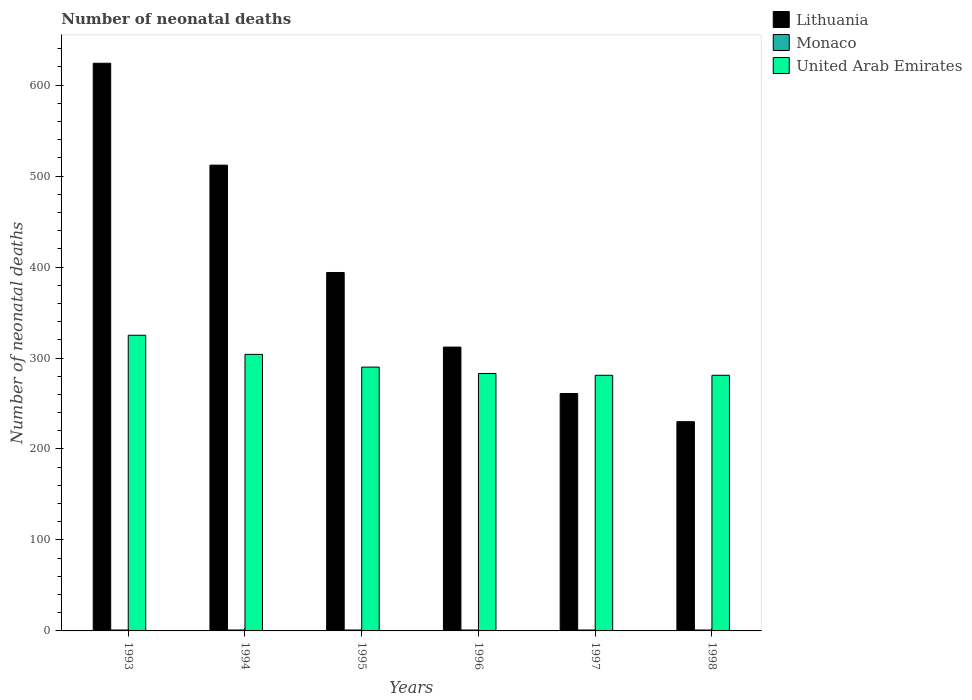Are the number of bars per tick equal to the number of legend labels?
Provide a short and direct response. Yes. Are the number of bars on each tick of the X-axis equal?
Your response must be concise. Yes. How many bars are there on the 5th tick from the left?
Offer a very short reply. 3. In how many cases, is the number of bars for a given year not equal to the number of legend labels?
Make the answer very short. 0. What is the number of neonatal deaths in in Lithuania in 1997?
Your answer should be very brief. 261. Across all years, what is the maximum number of neonatal deaths in in United Arab Emirates?
Keep it short and to the point. 325. Across all years, what is the minimum number of neonatal deaths in in Monaco?
Provide a succinct answer. 1. In which year was the number of neonatal deaths in in United Arab Emirates maximum?
Give a very brief answer. 1993. What is the difference between the number of neonatal deaths in in United Arab Emirates in 1996 and that in 1997?
Make the answer very short. 2. What is the difference between the number of neonatal deaths in in Monaco in 1993 and the number of neonatal deaths in in United Arab Emirates in 1994?
Your response must be concise. -303. In the year 1997, what is the difference between the number of neonatal deaths in in Monaco and number of neonatal deaths in in Lithuania?
Ensure brevity in your answer.  -260. In how many years, is the number of neonatal deaths in in Monaco greater than 260?
Offer a terse response. 0. What is the ratio of the number of neonatal deaths in in Lithuania in 1993 to that in 1996?
Your response must be concise. 2. What is the difference between the highest and the second highest number of neonatal deaths in in United Arab Emirates?
Provide a short and direct response. 21. What is the difference between the highest and the lowest number of neonatal deaths in in Lithuania?
Provide a short and direct response. 394. In how many years, is the number of neonatal deaths in in United Arab Emirates greater than the average number of neonatal deaths in in United Arab Emirates taken over all years?
Offer a terse response. 2. Is the sum of the number of neonatal deaths in in Lithuania in 1993 and 1995 greater than the maximum number of neonatal deaths in in United Arab Emirates across all years?
Give a very brief answer. Yes. What does the 2nd bar from the left in 1997 represents?
Provide a succinct answer. Monaco. What does the 3rd bar from the right in 1993 represents?
Offer a very short reply. Lithuania. How many bars are there?
Your answer should be compact. 18. Are all the bars in the graph horizontal?
Your response must be concise. No. What is the difference between two consecutive major ticks on the Y-axis?
Give a very brief answer. 100. Does the graph contain any zero values?
Ensure brevity in your answer.  No. Does the graph contain grids?
Your answer should be compact. No. Where does the legend appear in the graph?
Give a very brief answer. Top right. How many legend labels are there?
Your answer should be compact. 3. How are the legend labels stacked?
Ensure brevity in your answer.  Vertical. What is the title of the graph?
Offer a terse response. Number of neonatal deaths. What is the label or title of the Y-axis?
Your answer should be very brief. Number of neonatal deaths. What is the Number of neonatal deaths in Lithuania in 1993?
Your answer should be very brief. 624. What is the Number of neonatal deaths of Monaco in 1993?
Provide a succinct answer. 1. What is the Number of neonatal deaths of United Arab Emirates in 1993?
Your response must be concise. 325. What is the Number of neonatal deaths of Lithuania in 1994?
Offer a very short reply. 512. What is the Number of neonatal deaths in United Arab Emirates in 1994?
Make the answer very short. 304. What is the Number of neonatal deaths of Lithuania in 1995?
Offer a terse response. 394. What is the Number of neonatal deaths of United Arab Emirates in 1995?
Provide a short and direct response. 290. What is the Number of neonatal deaths in Lithuania in 1996?
Offer a very short reply. 312. What is the Number of neonatal deaths in United Arab Emirates in 1996?
Provide a short and direct response. 283. What is the Number of neonatal deaths of Lithuania in 1997?
Keep it short and to the point. 261. What is the Number of neonatal deaths in Monaco in 1997?
Offer a terse response. 1. What is the Number of neonatal deaths in United Arab Emirates in 1997?
Ensure brevity in your answer.  281. What is the Number of neonatal deaths in Lithuania in 1998?
Provide a succinct answer. 230. What is the Number of neonatal deaths of United Arab Emirates in 1998?
Provide a short and direct response. 281. Across all years, what is the maximum Number of neonatal deaths of Lithuania?
Ensure brevity in your answer.  624. Across all years, what is the maximum Number of neonatal deaths in Monaco?
Your response must be concise. 1. Across all years, what is the maximum Number of neonatal deaths in United Arab Emirates?
Your answer should be very brief. 325. Across all years, what is the minimum Number of neonatal deaths in Lithuania?
Offer a very short reply. 230. Across all years, what is the minimum Number of neonatal deaths in United Arab Emirates?
Offer a terse response. 281. What is the total Number of neonatal deaths of Lithuania in the graph?
Make the answer very short. 2333. What is the total Number of neonatal deaths of Monaco in the graph?
Your answer should be compact. 6. What is the total Number of neonatal deaths of United Arab Emirates in the graph?
Give a very brief answer. 1764. What is the difference between the Number of neonatal deaths in Lithuania in 1993 and that in 1994?
Keep it short and to the point. 112. What is the difference between the Number of neonatal deaths in United Arab Emirates in 1993 and that in 1994?
Your answer should be very brief. 21. What is the difference between the Number of neonatal deaths of Lithuania in 1993 and that in 1995?
Offer a very short reply. 230. What is the difference between the Number of neonatal deaths in Monaco in 1993 and that in 1995?
Provide a succinct answer. 0. What is the difference between the Number of neonatal deaths of Lithuania in 1993 and that in 1996?
Your answer should be compact. 312. What is the difference between the Number of neonatal deaths of Monaco in 1993 and that in 1996?
Provide a short and direct response. 0. What is the difference between the Number of neonatal deaths of United Arab Emirates in 1993 and that in 1996?
Provide a succinct answer. 42. What is the difference between the Number of neonatal deaths of Lithuania in 1993 and that in 1997?
Provide a short and direct response. 363. What is the difference between the Number of neonatal deaths of Monaco in 1993 and that in 1997?
Make the answer very short. 0. What is the difference between the Number of neonatal deaths in Lithuania in 1993 and that in 1998?
Keep it short and to the point. 394. What is the difference between the Number of neonatal deaths of Lithuania in 1994 and that in 1995?
Offer a terse response. 118. What is the difference between the Number of neonatal deaths of Lithuania in 1994 and that in 1996?
Offer a terse response. 200. What is the difference between the Number of neonatal deaths of United Arab Emirates in 1994 and that in 1996?
Provide a succinct answer. 21. What is the difference between the Number of neonatal deaths of Lithuania in 1994 and that in 1997?
Provide a short and direct response. 251. What is the difference between the Number of neonatal deaths in Monaco in 1994 and that in 1997?
Provide a succinct answer. 0. What is the difference between the Number of neonatal deaths of Lithuania in 1994 and that in 1998?
Give a very brief answer. 282. What is the difference between the Number of neonatal deaths in Monaco in 1994 and that in 1998?
Your answer should be very brief. 0. What is the difference between the Number of neonatal deaths in United Arab Emirates in 1994 and that in 1998?
Give a very brief answer. 23. What is the difference between the Number of neonatal deaths in Lithuania in 1995 and that in 1996?
Provide a short and direct response. 82. What is the difference between the Number of neonatal deaths of Monaco in 1995 and that in 1996?
Provide a short and direct response. 0. What is the difference between the Number of neonatal deaths in United Arab Emirates in 1995 and that in 1996?
Keep it short and to the point. 7. What is the difference between the Number of neonatal deaths in Lithuania in 1995 and that in 1997?
Give a very brief answer. 133. What is the difference between the Number of neonatal deaths of Lithuania in 1995 and that in 1998?
Offer a very short reply. 164. What is the difference between the Number of neonatal deaths of Monaco in 1997 and that in 1998?
Your response must be concise. 0. What is the difference between the Number of neonatal deaths in United Arab Emirates in 1997 and that in 1998?
Your answer should be compact. 0. What is the difference between the Number of neonatal deaths in Lithuania in 1993 and the Number of neonatal deaths in Monaco in 1994?
Keep it short and to the point. 623. What is the difference between the Number of neonatal deaths in Lithuania in 1993 and the Number of neonatal deaths in United Arab Emirates in 1994?
Your response must be concise. 320. What is the difference between the Number of neonatal deaths in Monaco in 1993 and the Number of neonatal deaths in United Arab Emirates in 1994?
Ensure brevity in your answer.  -303. What is the difference between the Number of neonatal deaths in Lithuania in 1993 and the Number of neonatal deaths in Monaco in 1995?
Give a very brief answer. 623. What is the difference between the Number of neonatal deaths in Lithuania in 1993 and the Number of neonatal deaths in United Arab Emirates in 1995?
Provide a succinct answer. 334. What is the difference between the Number of neonatal deaths of Monaco in 1993 and the Number of neonatal deaths of United Arab Emirates in 1995?
Provide a succinct answer. -289. What is the difference between the Number of neonatal deaths in Lithuania in 1993 and the Number of neonatal deaths in Monaco in 1996?
Offer a very short reply. 623. What is the difference between the Number of neonatal deaths in Lithuania in 1993 and the Number of neonatal deaths in United Arab Emirates in 1996?
Make the answer very short. 341. What is the difference between the Number of neonatal deaths in Monaco in 1993 and the Number of neonatal deaths in United Arab Emirates in 1996?
Your answer should be very brief. -282. What is the difference between the Number of neonatal deaths in Lithuania in 1993 and the Number of neonatal deaths in Monaco in 1997?
Give a very brief answer. 623. What is the difference between the Number of neonatal deaths in Lithuania in 1993 and the Number of neonatal deaths in United Arab Emirates in 1997?
Provide a succinct answer. 343. What is the difference between the Number of neonatal deaths of Monaco in 1993 and the Number of neonatal deaths of United Arab Emirates in 1997?
Provide a short and direct response. -280. What is the difference between the Number of neonatal deaths in Lithuania in 1993 and the Number of neonatal deaths in Monaco in 1998?
Ensure brevity in your answer.  623. What is the difference between the Number of neonatal deaths of Lithuania in 1993 and the Number of neonatal deaths of United Arab Emirates in 1998?
Keep it short and to the point. 343. What is the difference between the Number of neonatal deaths in Monaco in 1993 and the Number of neonatal deaths in United Arab Emirates in 1998?
Your answer should be compact. -280. What is the difference between the Number of neonatal deaths in Lithuania in 1994 and the Number of neonatal deaths in Monaco in 1995?
Offer a very short reply. 511. What is the difference between the Number of neonatal deaths of Lithuania in 1994 and the Number of neonatal deaths of United Arab Emirates in 1995?
Ensure brevity in your answer.  222. What is the difference between the Number of neonatal deaths of Monaco in 1994 and the Number of neonatal deaths of United Arab Emirates in 1995?
Keep it short and to the point. -289. What is the difference between the Number of neonatal deaths in Lithuania in 1994 and the Number of neonatal deaths in Monaco in 1996?
Ensure brevity in your answer.  511. What is the difference between the Number of neonatal deaths in Lithuania in 1994 and the Number of neonatal deaths in United Arab Emirates in 1996?
Your answer should be very brief. 229. What is the difference between the Number of neonatal deaths of Monaco in 1994 and the Number of neonatal deaths of United Arab Emirates in 1996?
Provide a short and direct response. -282. What is the difference between the Number of neonatal deaths of Lithuania in 1994 and the Number of neonatal deaths of Monaco in 1997?
Give a very brief answer. 511. What is the difference between the Number of neonatal deaths in Lithuania in 1994 and the Number of neonatal deaths in United Arab Emirates in 1997?
Provide a succinct answer. 231. What is the difference between the Number of neonatal deaths of Monaco in 1994 and the Number of neonatal deaths of United Arab Emirates in 1997?
Make the answer very short. -280. What is the difference between the Number of neonatal deaths of Lithuania in 1994 and the Number of neonatal deaths of Monaco in 1998?
Your answer should be compact. 511. What is the difference between the Number of neonatal deaths of Lithuania in 1994 and the Number of neonatal deaths of United Arab Emirates in 1998?
Provide a succinct answer. 231. What is the difference between the Number of neonatal deaths in Monaco in 1994 and the Number of neonatal deaths in United Arab Emirates in 1998?
Provide a short and direct response. -280. What is the difference between the Number of neonatal deaths in Lithuania in 1995 and the Number of neonatal deaths in Monaco in 1996?
Provide a short and direct response. 393. What is the difference between the Number of neonatal deaths of Lithuania in 1995 and the Number of neonatal deaths of United Arab Emirates in 1996?
Offer a very short reply. 111. What is the difference between the Number of neonatal deaths of Monaco in 1995 and the Number of neonatal deaths of United Arab Emirates in 1996?
Your answer should be compact. -282. What is the difference between the Number of neonatal deaths of Lithuania in 1995 and the Number of neonatal deaths of Monaco in 1997?
Your response must be concise. 393. What is the difference between the Number of neonatal deaths of Lithuania in 1995 and the Number of neonatal deaths of United Arab Emirates in 1997?
Give a very brief answer. 113. What is the difference between the Number of neonatal deaths of Monaco in 1995 and the Number of neonatal deaths of United Arab Emirates in 1997?
Your answer should be very brief. -280. What is the difference between the Number of neonatal deaths of Lithuania in 1995 and the Number of neonatal deaths of Monaco in 1998?
Offer a very short reply. 393. What is the difference between the Number of neonatal deaths in Lithuania in 1995 and the Number of neonatal deaths in United Arab Emirates in 1998?
Your answer should be compact. 113. What is the difference between the Number of neonatal deaths in Monaco in 1995 and the Number of neonatal deaths in United Arab Emirates in 1998?
Provide a short and direct response. -280. What is the difference between the Number of neonatal deaths of Lithuania in 1996 and the Number of neonatal deaths of Monaco in 1997?
Offer a terse response. 311. What is the difference between the Number of neonatal deaths in Lithuania in 1996 and the Number of neonatal deaths in United Arab Emirates in 1997?
Your answer should be very brief. 31. What is the difference between the Number of neonatal deaths of Monaco in 1996 and the Number of neonatal deaths of United Arab Emirates in 1997?
Provide a succinct answer. -280. What is the difference between the Number of neonatal deaths in Lithuania in 1996 and the Number of neonatal deaths in Monaco in 1998?
Offer a terse response. 311. What is the difference between the Number of neonatal deaths of Lithuania in 1996 and the Number of neonatal deaths of United Arab Emirates in 1998?
Offer a very short reply. 31. What is the difference between the Number of neonatal deaths in Monaco in 1996 and the Number of neonatal deaths in United Arab Emirates in 1998?
Offer a very short reply. -280. What is the difference between the Number of neonatal deaths of Lithuania in 1997 and the Number of neonatal deaths of Monaco in 1998?
Offer a very short reply. 260. What is the difference between the Number of neonatal deaths in Monaco in 1997 and the Number of neonatal deaths in United Arab Emirates in 1998?
Your answer should be very brief. -280. What is the average Number of neonatal deaths in Lithuania per year?
Offer a terse response. 388.83. What is the average Number of neonatal deaths in Monaco per year?
Give a very brief answer. 1. What is the average Number of neonatal deaths of United Arab Emirates per year?
Your response must be concise. 294. In the year 1993, what is the difference between the Number of neonatal deaths in Lithuania and Number of neonatal deaths in Monaco?
Provide a short and direct response. 623. In the year 1993, what is the difference between the Number of neonatal deaths in Lithuania and Number of neonatal deaths in United Arab Emirates?
Make the answer very short. 299. In the year 1993, what is the difference between the Number of neonatal deaths of Monaco and Number of neonatal deaths of United Arab Emirates?
Offer a very short reply. -324. In the year 1994, what is the difference between the Number of neonatal deaths in Lithuania and Number of neonatal deaths in Monaco?
Give a very brief answer. 511. In the year 1994, what is the difference between the Number of neonatal deaths of Lithuania and Number of neonatal deaths of United Arab Emirates?
Provide a succinct answer. 208. In the year 1994, what is the difference between the Number of neonatal deaths in Monaco and Number of neonatal deaths in United Arab Emirates?
Make the answer very short. -303. In the year 1995, what is the difference between the Number of neonatal deaths of Lithuania and Number of neonatal deaths of Monaco?
Ensure brevity in your answer.  393. In the year 1995, what is the difference between the Number of neonatal deaths in Lithuania and Number of neonatal deaths in United Arab Emirates?
Your response must be concise. 104. In the year 1995, what is the difference between the Number of neonatal deaths of Monaco and Number of neonatal deaths of United Arab Emirates?
Your response must be concise. -289. In the year 1996, what is the difference between the Number of neonatal deaths in Lithuania and Number of neonatal deaths in Monaco?
Give a very brief answer. 311. In the year 1996, what is the difference between the Number of neonatal deaths in Monaco and Number of neonatal deaths in United Arab Emirates?
Give a very brief answer. -282. In the year 1997, what is the difference between the Number of neonatal deaths in Lithuania and Number of neonatal deaths in Monaco?
Give a very brief answer. 260. In the year 1997, what is the difference between the Number of neonatal deaths in Lithuania and Number of neonatal deaths in United Arab Emirates?
Offer a very short reply. -20. In the year 1997, what is the difference between the Number of neonatal deaths of Monaco and Number of neonatal deaths of United Arab Emirates?
Ensure brevity in your answer.  -280. In the year 1998, what is the difference between the Number of neonatal deaths of Lithuania and Number of neonatal deaths of Monaco?
Your answer should be very brief. 229. In the year 1998, what is the difference between the Number of neonatal deaths in Lithuania and Number of neonatal deaths in United Arab Emirates?
Give a very brief answer. -51. In the year 1998, what is the difference between the Number of neonatal deaths of Monaco and Number of neonatal deaths of United Arab Emirates?
Make the answer very short. -280. What is the ratio of the Number of neonatal deaths in Lithuania in 1993 to that in 1994?
Ensure brevity in your answer.  1.22. What is the ratio of the Number of neonatal deaths in Monaco in 1993 to that in 1994?
Offer a very short reply. 1. What is the ratio of the Number of neonatal deaths of United Arab Emirates in 1993 to that in 1994?
Make the answer very short. 1.07. What is the ratio of the Number of neonatal deaths of Lithuania in 1993 to that in 1995?
Provide a succinct answer. 1.58. What is the ratio of the Number of neonatal deaths of United Arab Emirates in 1993 to that in 1995?
Your response must be concise. 1.12. What is the ratio of the Number of neonatal deaths of Lithuania in 1993 to that in 1996?
Offer a very short reply. 2. What is the ratio of the Number of neonatal deaths of United Arab Emirates in 1993 to that in 1996?
Offer a very short reply. 1.15. What is the ratio of the Number of neonatal deaths of Lithuania in 1993 to that in 1997?
Offer a terse response. 2.39. What is the ratio of the Number of neonatal deaths in Monaco in 1993 to that in 1997?
Give a very brief answer. 1. What is the ratio of the Number of neonatal deaths of United Arab Emirates in 1993 to that in 1997?
Offer a very short reply. 1.16. What is the ratio of the Number of neonatal deaths of Lithuania in 1993 to that in 1998?
Keep it short and to the point. 2.71. What is the ratio of the Number of neonatal deaths of United Arab Emirates in 1993 to that in 1998?
Your answer should be compact. 1.16. What is the ratio of the Number of neonatal deaths of Lithuania in 1994 to that in 1995?
Offer a very short reply. 1.3. What is the ratio of the Number of neonatal deaths in United Arab Emirates in 1994 to that in 1995?
Provide a succinct answer. 1.05. What is the ratio of the Number of neonatal deaths in Lithuania in 1994 to that in 1996?
Make the answer very short. 1.64. What is the ratio of the Number of neonatal deaths in Monaco in 1994 to that in 1996?
Offer a very short reply. 1. What is the ratio of the Number of neonatal deaths in United Arab Emirates in 1994 to that in 1996?
Provide a short and direct response. 1.07. What is the ratio of the Number of neonatal deaths of Lithuania in 1994 to that in 1997?
Your answer should be compact. 1.96. What is the ratio of the Number of neonatal deaths of Monaco in 1994 to that in 1997?
Your response must be concise. 1. What is the ratio of the Number of neonatal deaths in United Arab Emirates in 1994 to that in 1997?
Keep it short and to the point. 1.08. What is the ratio of the Number of neonatal deaths of Lithuania in 1994 to that in 1998?
Your answer should be compact. 2.23. What is the ratio of the Number of neonatal deaths of United Arab Emirates in 1994 to that in 1998?
Your response must be concise. 1.08. What is the ratio of the Number of neonatal deaths in Lithuania in 1995 to that in 1996?
Provide a short and direct response. 1.26. What is the ratio of the Number of neonatal deaths of Monaco in 1995 to that in 1996?
Your response must be concise. 1. What is the ratio of the Number of neonatal deaths in United Arab Emirates in 1995 to that in 1996?
Make the answer very short. 1.02. What is the ratio of the Number of neonatal deaths of Lithuania in 1995 to that in 1997?
Your response must be concise. 1.51. What is the ratio of the Number of neonatal deaths of United Arab Emirates in 1995 to that in 1997?
Provide a succinct answer. 1.03. What is the ratio of the Number of neonatal deaths of Lithuania in 1995 to that in 1998?
Make the answer very short. 1.71. What is the ratio of the Number of neonatal deaths of Monaco in 1995 to that in 1998?
Your answer should be compact. 1. What is the ratio of the Number of neonatal deaths in United Arab Emirates in 1995 to that in 1998?
Your answer should be very brief. 1.03. What is the ratio of the Number of neonatal deaths in Lithuania in 1996 to that in 1997?
Keep it short and to the point. 1.2. What is the ratio of the Number of neonatal deaths in United Arab Emirates in 1996 to that in 1997?
Provide a succinct answer. 1.01. What is the ratio of the Number of neonatal deaths of Lithuania in 1996 to that in 1998?
Give a very brief answer. 1.36. What is the ratio of the Number of neonatal deaths in Monaco in 1996 to that in 1998?
Your answer should be very brief. 1. What is the ratio of the Number of neonatal deaths in United Arab Emirates in 1996 to that in 1998?
Your answer should be very brief. 1.01. What is the ratio of the Number of neonatal deaths in Lithuania in 1997 to that in 1998?
Offer a very short reply. 1.13. What is the difference between the highest and the second highest Number of neonatal deaths in Lithuania?
Give a very brief answer. 112. What is the difference between the highest and the second highest Number of neonatal deaths in Monaco?
Offer a very short reply. 0. What is the difference between the highest and the lowest Number of neonatal deaths of Lithuania?
Make the answer very short. 394. What is the difference between the highest and the lowest Number of neonatal deaths in Monaco?
Your answer should be very brief. 0. What is the difference between the highest and the lowest Number of neonatal deaths in United Arab Emirates?
Offer a very short reply. 44. 